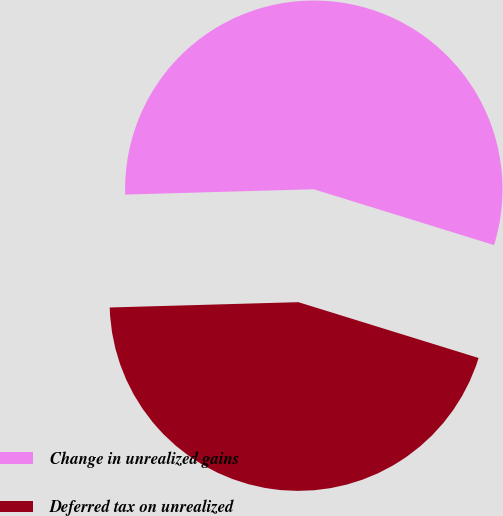<chart> <loc_0><loc_0><loc_500><loc_500><pie_chart><fcel>Change in unrealized gains<fcel>Deferred tax on unrealized<nl><fcel>55.23%<fcel>44.77%<nl></chart> 